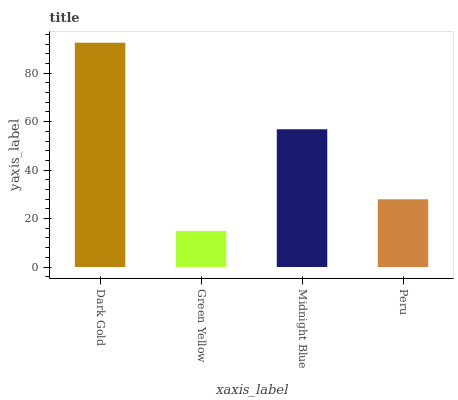Is Green Yellow the minimum?
Answer yes or no. Yes. Is Dark Gold the maximum?
Answer yes or no. Yes. Is Midnight Blue the minimum?
Answer yes or no. No. Is Midnight Blue the maximum?
Answer yes or no. No. Is Midnight Blue greater than Green Yellow?
Answer yes or no. Yes. Is Green Yellow less than Midnight Blue?
Answer yes or no. Yes. Is Green Yellow greater than Midnight Blue?
Answer yes or no. No. Is Midnight Blue less than Green Yellow?
Answer yes or no. No. Is Midnight Blue the high median?
Answer yes or no. Yes. Is Peru the low median?
Answer yes or no. Yes. Is Green Yellow the high median?
Answer yes or no. No. Is Dark Gold the low median?
Answer yes or no. No. 